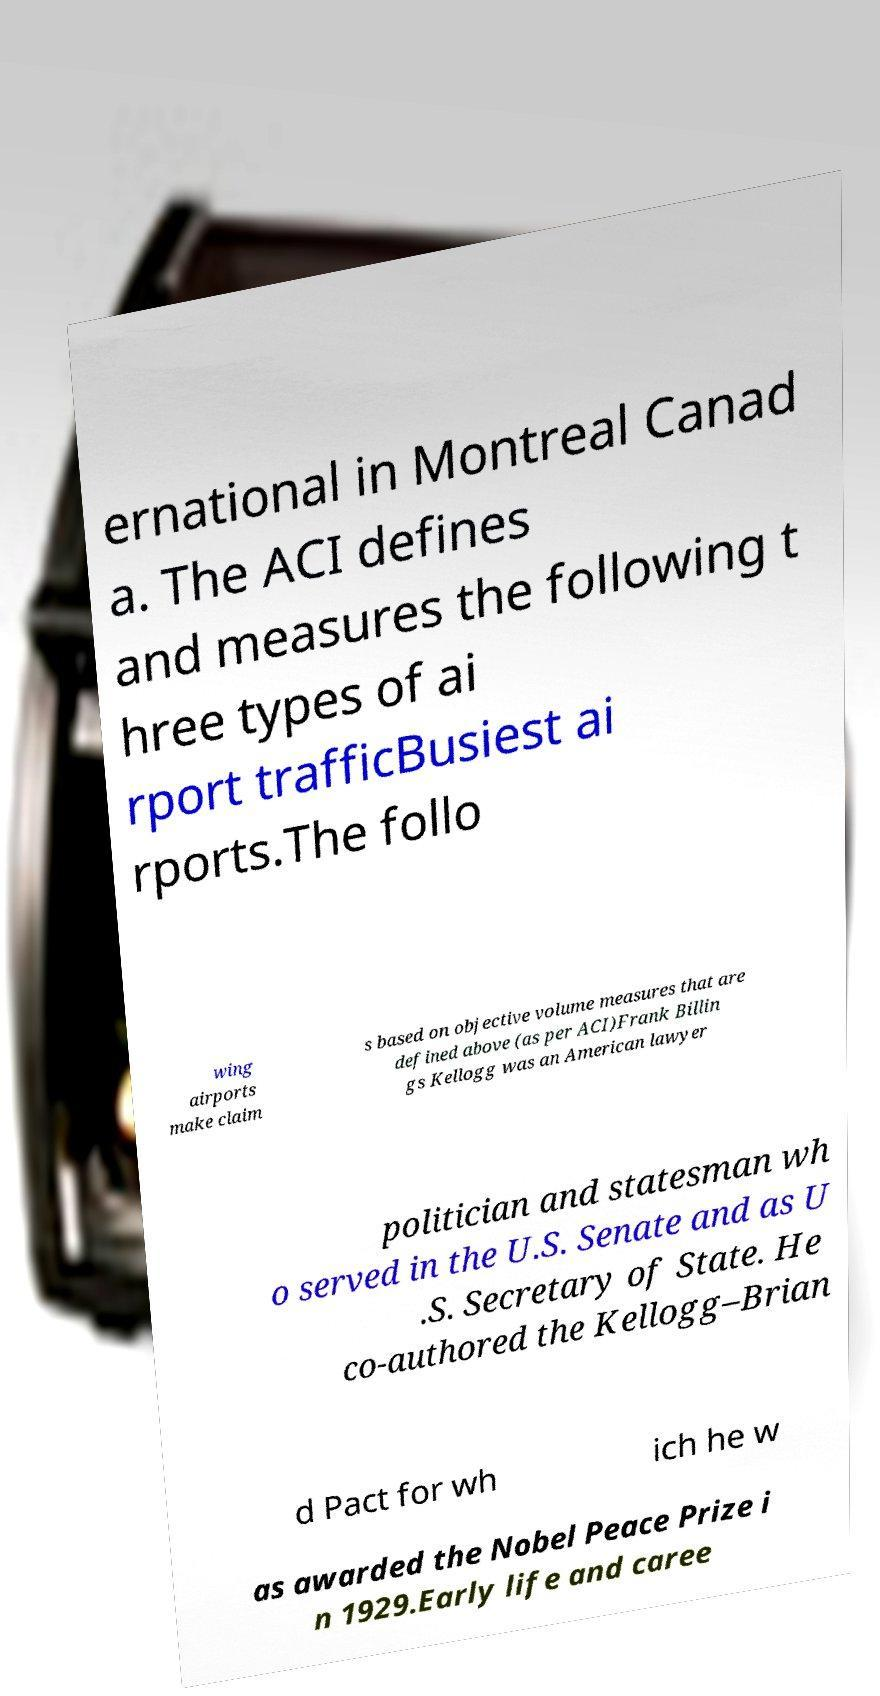Could you extract and type out the text from this image? ernational in Montreal Canad a. The ACI defines and measures the following t hree types of ai rport trafficBusiest ai rports.The follo wing airports make claim s based on objective volume measures that are defined above (as per ACI)Frank Billin gs Kellogg was an American lawyer politician and statesman wh o served in the U.S. Senate and as U .S. Secretary of State. He co-authored the Kellogg–Brian d Pact for wh ich he w as awarded the Nobel Peace Prize i n 1929.Early life and caree 